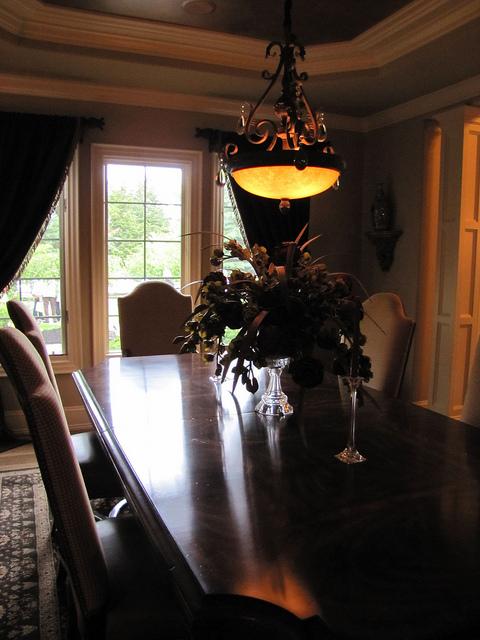Which room is this?
Concise answer only. Dining room. Is the table set for dinner?
Write a very short answer. No. What is the plant sitting on?
Write a very short answer. Table. 